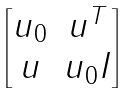<formula> <loc_0><loc_0><loc_500><loc_500>\begin{bmatrix} u _ { 0 } & u ^ { T } \\ u & u _ { 0 } I \end{bmatrix}</formula> 